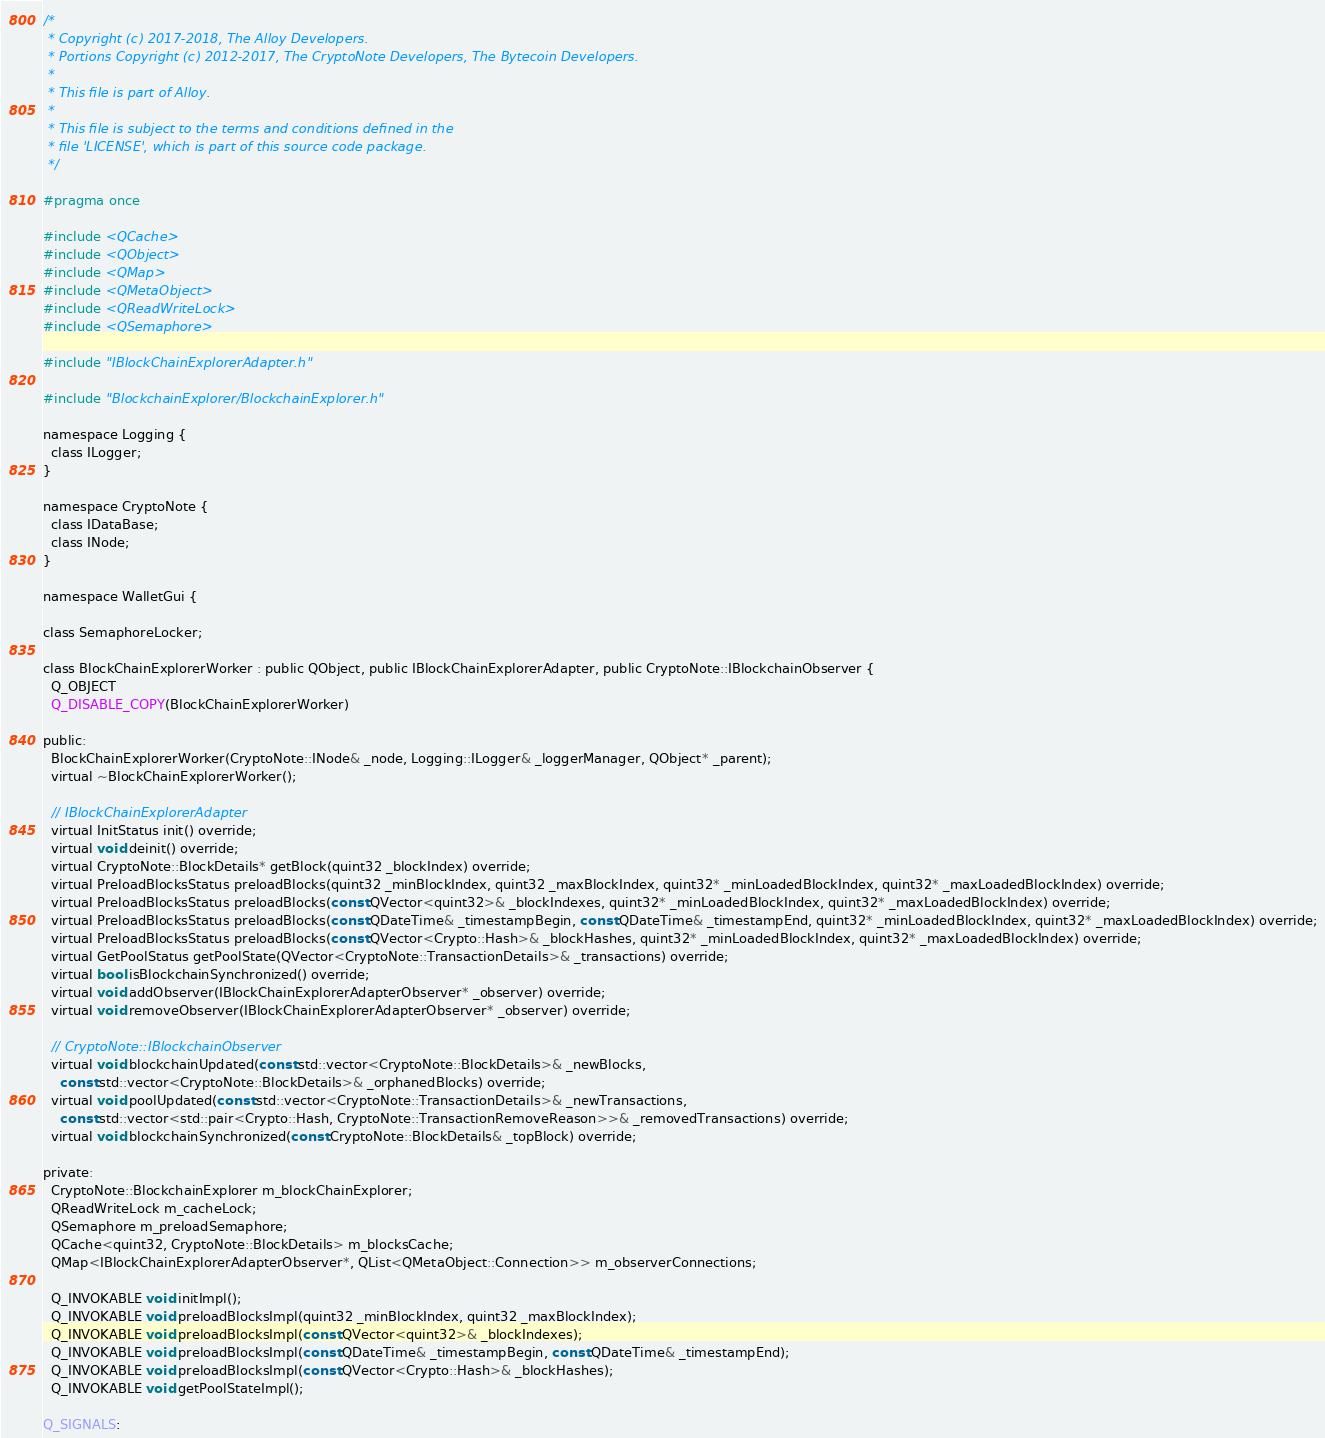<code> <loc_0><loc_0><loc_500><loc_500><_C_>/*
 * Copyright (c) 2017-2018, The Alloy Developers.
 * Portions Copyright (c) 2012-2017, The CryptoNote Developers, The Bytecoin Developers.
 *
 * This file is part of Alloy.
 *
 * This file is subject to the terms and conditions defined in the
 * file 'LICENSE', which is part of this source code package.
 */

#pragma once

#include <QCache>
#include <QObject>
#include <QMap>
#include <QMetaObject>
#include <QReadWriteLock>
#include <QSemaphore>

#include "IBlockChainExplorerAdapter.h"

#include "BlockchainExplorer/BlockchainExplorer.h"

namespace Logging {
  class ILogger;
}

namespace CryptoNote {
  class IDataBase;
  class INode;
}

namespace WalletGui {

class SemaphoreLocker;

class BlockChainExplorerWorker : public QObject, public IBlockChainExplorerAdapter, public CryptoNote::IBlockchainObserver {
  Q_OBJECT
  Q_DISABLE_COPY(BlockChainExplorerWorker)

public:
  BlockChainExplorerWorker(CryptoNote::INode& _node, Logging::ILogger& _loggerManager, QObject* _parent);
  virtual ~BlockChainExplorerWorker();

  // IBlockChainExplorerAdapter
  virtual InitStatus init() override;
  virtual void deinit() override;
  virtual CryptoNote::BlockDetails* getBlock(quint32 _blockIndex) override;
  virtual PreloadBlocksStatus preloadBlocks(quint32 _minBlockIndex, quint32 _maxBlockIndex, quint32* _minLoadedBlockIndex, quint32* _maxLoadedBlockIndex) override;
  virtual PreloadBlocksStatus preloadBlocks(const QVector<quint32>& _blockIndexes, quint32* _minLoadedBlockIndex, quint32* _maxLoadedBlockIndex) override;
  virtual PreloadBlocksStatus preloadBlocks(const QDateTime& _timestampBegin, const QDateTime& _timestampEnd, quint32* _minLoadedBlockIndex, quint32* _maxLoadedBlockIndex) override;
  virtual PreloadBlocksStatus preloadBlocks(const QVector<Crypto::Hash>& _blockHashes, quint32* _minLoadedBlockIndex, quint32* _maxLoadedBlockIndex) override;
  virtual GetPoolStatus getPoolState(QVector<CryptoNote::TransactionDetails>& _transactions) override;
  virtual bool isBlockchainSynchronized() override;
  virtual void addObserver(IBlockChainExplorerAdapterObserver* _observer) override;
  virtual void removeObserver(IBlockChainExplorerAdapterObserver* _observer) override;

  // CryptoNote::IBlockchainObserver
  virtual void blockchainUpdated(const std::vector<CryptoNote::BlockDetails>& _newBlocks,
    const std::vector<CryptoNote::BlockDetails>& _orphanedBlocks) override;
  virtual void poolUpdated(const std::vector<CryptoNote::TransactionDetails>& _newTransactions,
    const std::vector<std::pair<Crypto::Hash, CryptoNote::TransactionRemoveReason>>& _removedTransactions) override;
  virtual void blockchainSynchronized(const CryptoNote::BlockDetails& _topBlock) override;

private:
  CryptoNote::BlockchainExplorer m_blockChainExplorer;
  QReadWriteLock m_cacheLock;
  QSemaphore m_preloadSemaphore;
  QCache<quint32, CryptoNote::BlockDetails> m_blocksCache;
  QMap<IBlockChainExplorerAdapterObserver*, QList<QMetaObject::Connection>> m_observerConnections;

  Q_INVOKABLE void initImpl();
  Q_INVOKABLE void preloadBlocksImpl(quint32 _minBlockIndex, quint32 _maxBlockIndex);
  Q_INVOKABLE void preloadBlocksImpl(const QVector<quint32>& _blockIndexes);
  Q_INVOKABLE void preloadBlocksImpl(const QDateTime& _timestampBegin, const QDateTime& _timestampEnd);
  Q_INVOKABLE void preloadBlocksImpl(const QVector<Crypto::Hash>& _blockHashes);
  Q_INVOKABLE void getPoolStateImpl();

Q_SIGNALS:</code> 